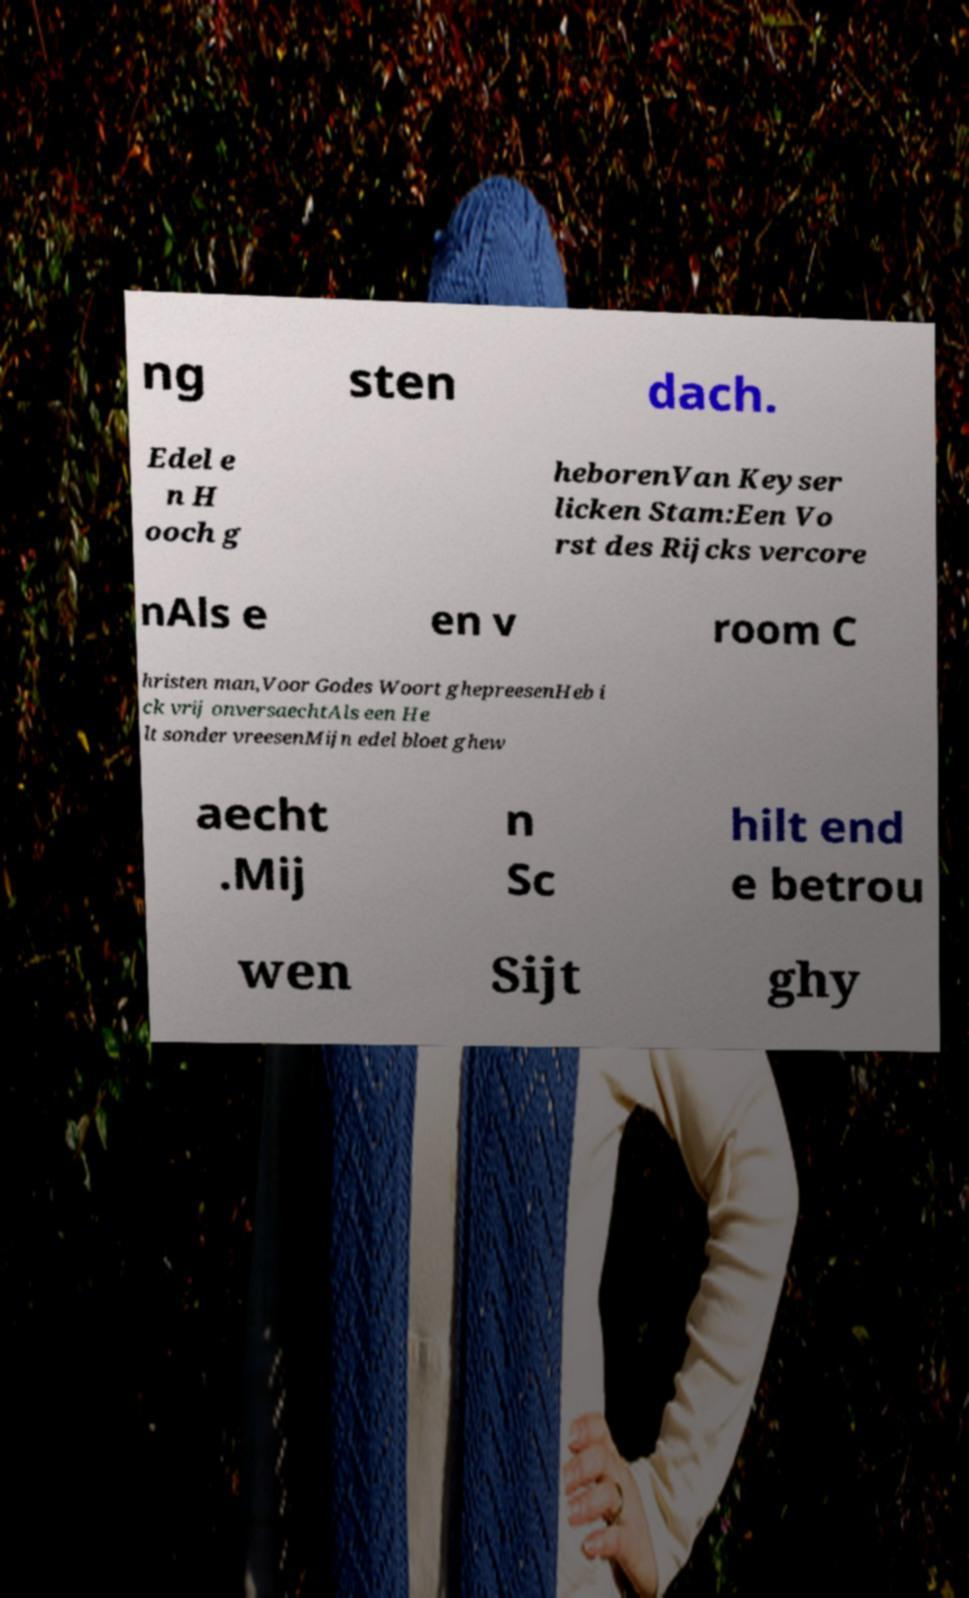For documentation purposes, I need the text within this image transcribed. Could you provide that? ng sten dach. Edel e n H ooch g heborenVan Keyser licken Stam:Een Vo rst des Rijcks vercore nAls e en v room C hristen man,Voor Godes Woort ghepreesenHeb i ck vrij onversaechtAls een He lt sonder vreesenMijn edel bloet ghew aecht .Mij n Sc hilt end e betrou wen Sijt ghy 